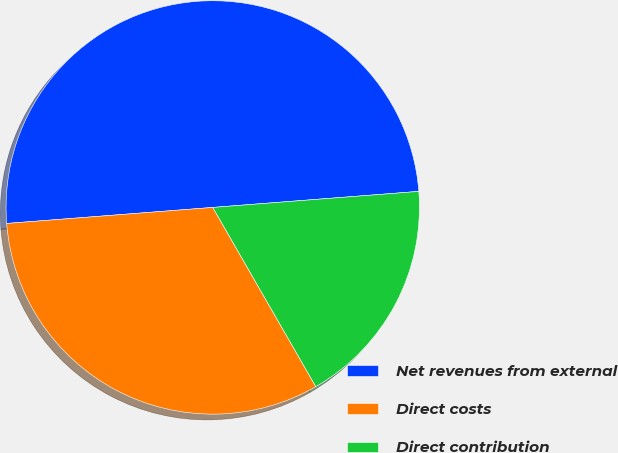<chart> <loc_0><loc_0><loc_500><loc_500><pie_chart><fcel>Net revenues from external<fcel>Direct costs<fcel>Direct contribution<nl><fcel>50.0%<fcel>32.07%<fcel>17.93%<nl></chart> 